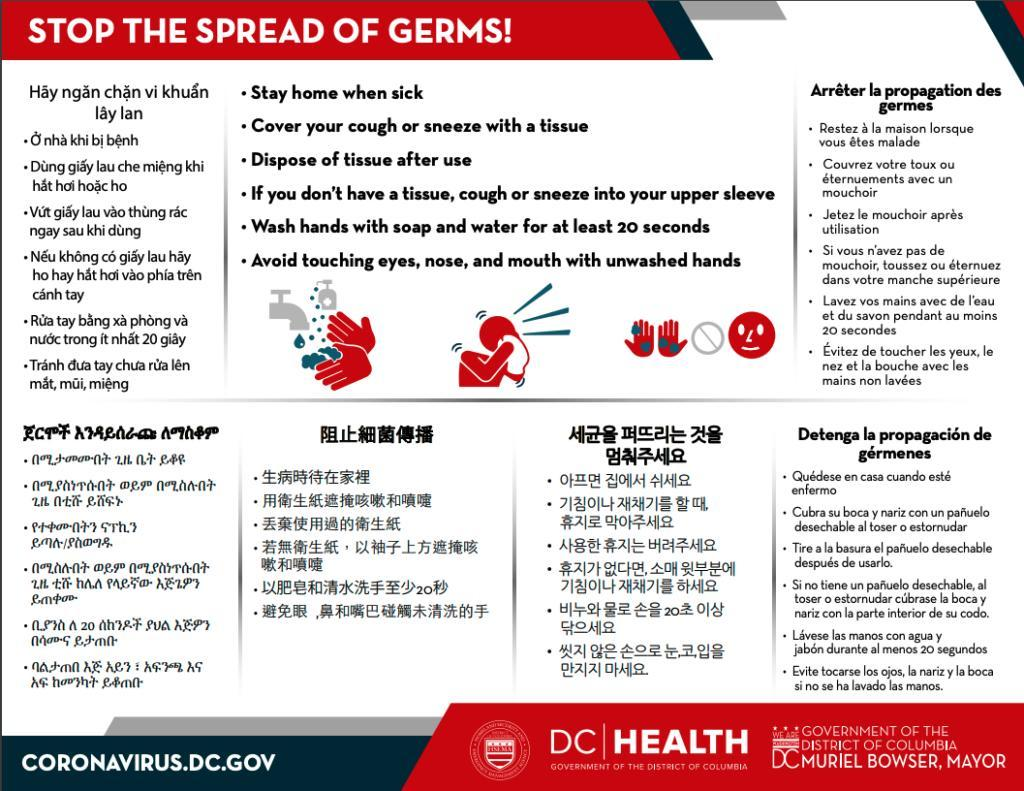How many images are shown here?
Answer the question with a short phrase. 3 What is the third instruction in English? Dispose of tissue after use In the second image what is in the person's hands? Tissue Which instruction is represented by the last image? Avoid touching eyes, nose, and mouth with unwashed hands How many instructions are mentioned in English? 6 What is fourth instruction in English? If you don't have a tissue, cough or sneeze into your upper sleeve Name the parts of your face you should not touch with unclean hands? Eyes, nose,  and mouth Which instruction is represented by the second image? Cover your cough or sneeze with a tissue Which instruction is represented by the first image? Wash hands with soap and water for at least 20 seconds 